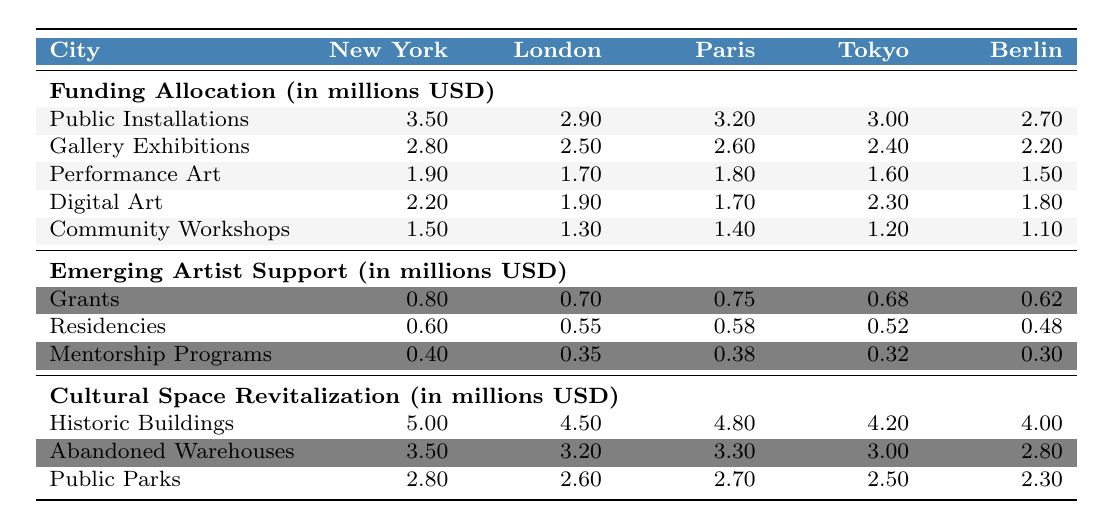What's the highest funding allocation for Public Installations? The highest funding allocation for Public Installations is found in New York, which is $3,500,000.
Answer: $3,500,000 Which city has the least funding for Community Workshops? Berlin has the least funding for Community Workshops, with $1,100,000 allocated.
Answer: $1,100,000 What is the total funding for Gallery Exhibitions across all cities? To find the total funding for Gallery Exhibitions, we sum the values: 2,800,000 (NY) + 2,500,000 (London) + 2,600,000 (Paris) + 2,400,000 (Tokyo) + 2,200,000 (Berlin) = 14,500,000.
Answer: $14,500,000 Did Tokyo allocate more funding to Digital Art than to Performance Art? Yes, Tokyo allocated $2,300,000 to Digital Art and $1,600,000 to Performance Art, which means Digital Art received more funding.
Answer: Yes What is the average funding for Emerging Artist Support in Berlin? The components in Berlin are Grants ($620,000), Residencies ($480,000), and Mentorship Programs ($300,000). The total is 620,000 + 480,000 + 300,000 = 1,400,000, and the average is 1,400,000 / 3 ≈ 466,667.
Answer: $466,667 Which city has the highest funding for Historic Buildings and how much? New York has the highest funding for Historic Buildings at $5,000,000.
Answer: New York, $5,000,000 Is the total funding for Community Workshops in Paris greater than the combined funding for Performance Art in New York and London? The total funding for Community Workshops in Paris is $1,400,000. The combined funding for Performance Art in New York ($1,900,000) and London ($1,700,000) is $3,600,000. Since $1,400,000 is less than $3,600,000, the answer is no.
Answer: No Which project type in New York receives the most funding for all categories? In New York, Public Installations receive the most funding at $3,500,000 compared to other project types there.
Answer: Public Installations, $3,500,000 How much more funding for Digital Art does Tokyo receive compared to Berlin? Tokyo receives $2,300,000 for Digital Art and Berlin receives $1,800,000, so the difference is $2,300,000 - $1,800,000 = $500,000.
Answer: $500,000 What percentage of the total funding for Cultural Space Revitalization in Paris is allocated to Historic Buildings? The funding for Historic Buildings in Paris is $4,800,000. The total funding for Cultural Space Revitalization is 4,800,000 + 3,300,000 + 2,700,000 = 10,800,000. The percentage is (4,800,000 / 10,800,000) * 100 ≈ 44.44%.
Answer: 44.44% 